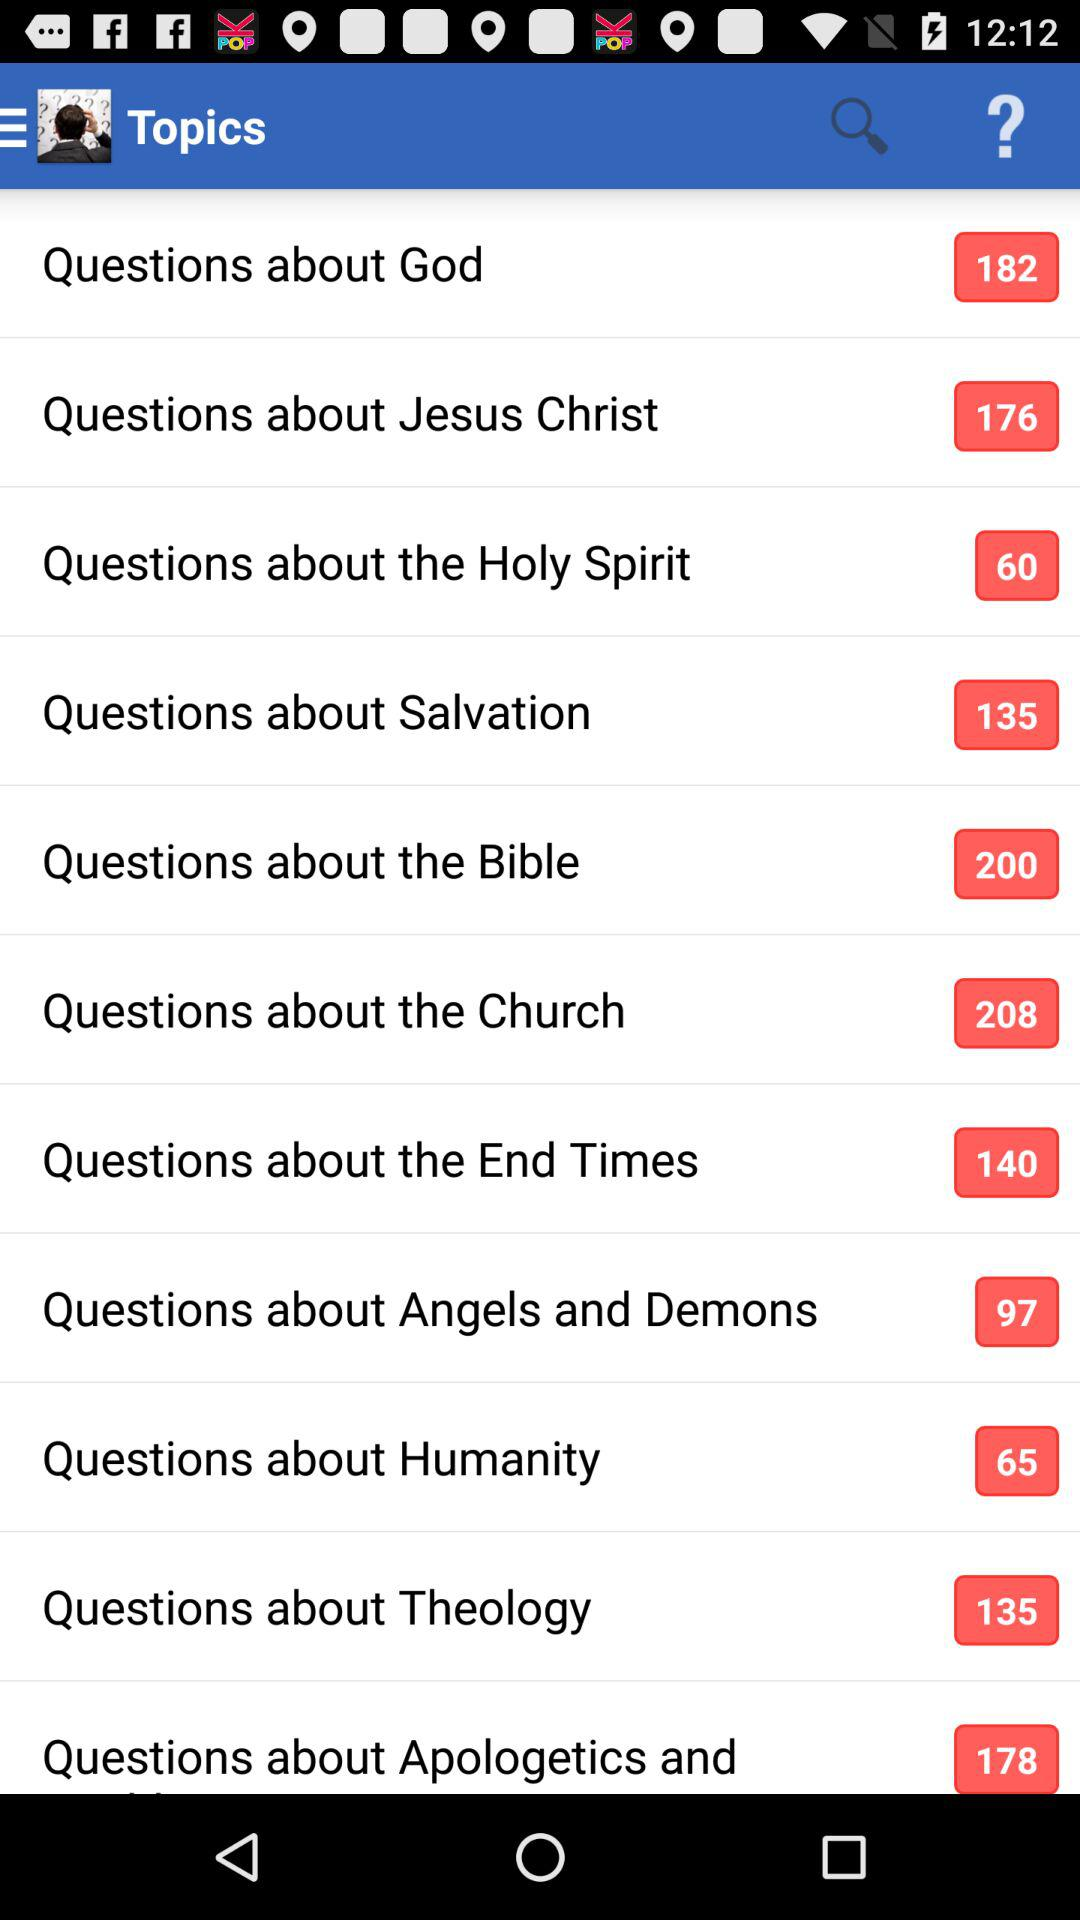What is the total number of questions about the "Bible"? The total number of questions about the "Bible" is 200. 